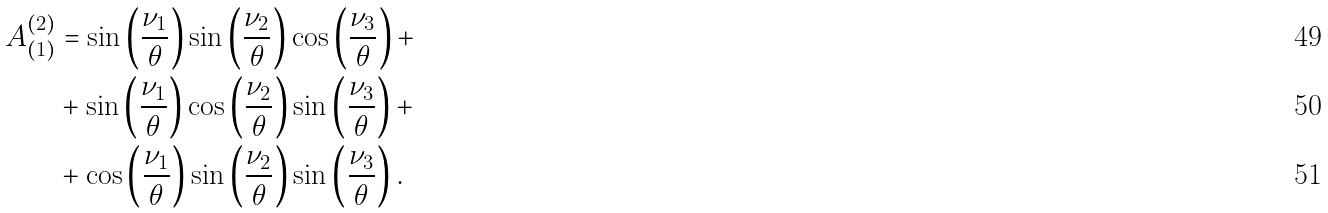Convert formula to latex. <formula><loc_0><loc_0><loc_500><loc_500>A _ { ( 1 ) } ^ { ( 2 ) } & = \sin \left ( \frac { \nu _ { 1 } } { \theta } \right ) \sin \left ( \frac { \nu _ { 2 } } { \theta } \right ) \cos \left ( \frac { \nu _ { 3 } } { \theta } \right ) + \\ & + \sin \left ( \frac { \nu _ { 1 } } { \theta } \right ) \cos \left ( \frac { \nu _ { 2 } } { \theta } \right ) \sin \left ( \frac { \nu _ { 3 } } { \theta } \right ) + \\ & + \cos \left ( \frac { \nu _ { 1 } } { \theta } \right ) \sin \left ( \frac { \nu _ { 2 } } { \theta } \right ) \sin \left ( \frac { \nu _ { 3 } } { \theta } \right ) .</formula> 